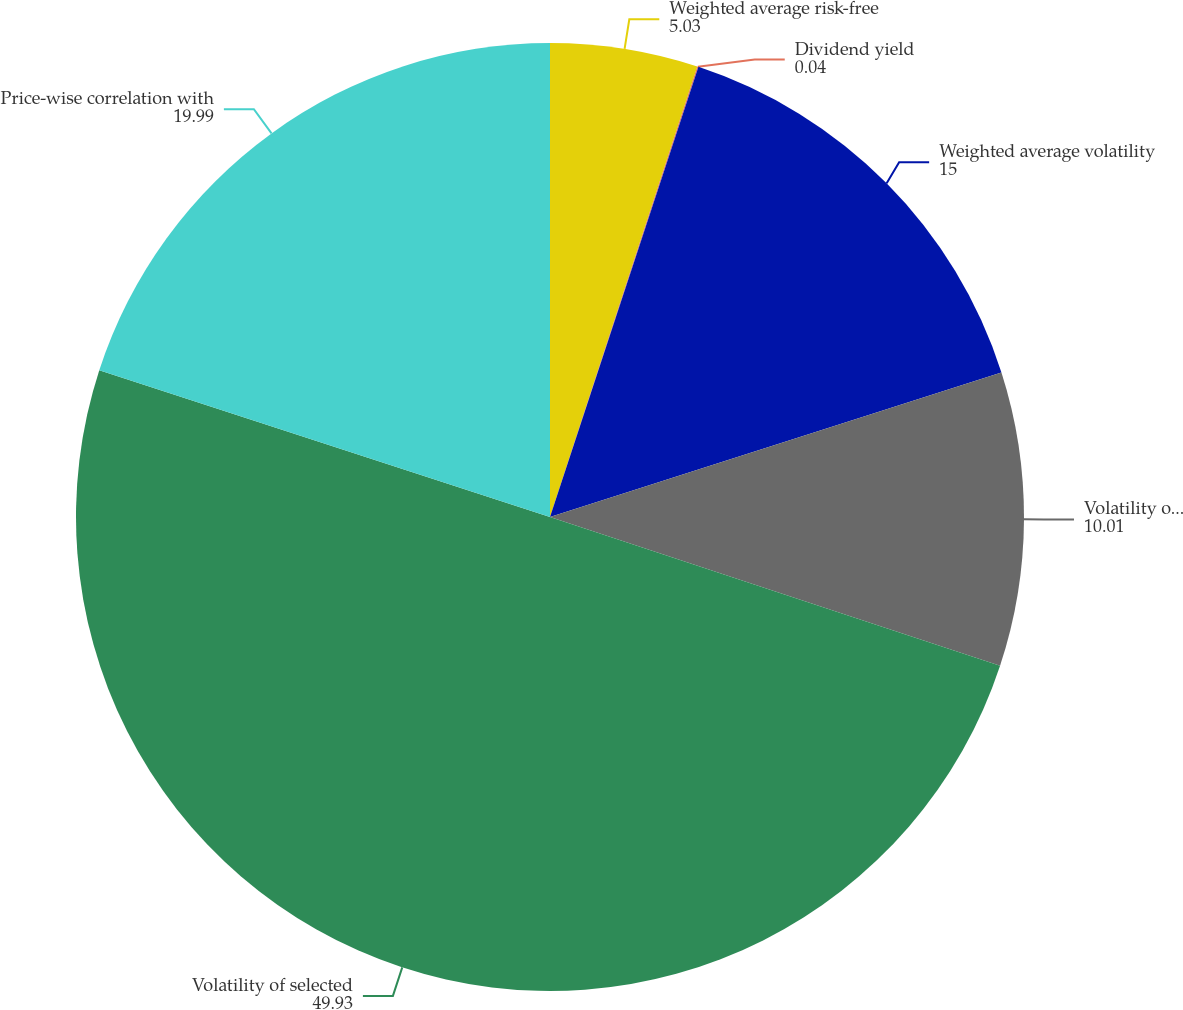<chart> <loc_0><loc_0><loc_500><loc_500><pie_chart><fcel>Weighted average risk-free<fcel>Dividend yield<fcel>Weighted average volatility<fcel>Volatility of Agilent shares<fcel>Volatility of selected<fcel>Price-wise correlation with<nl><fcel>5.03%<fcel>0.04%<fcel>15.0%<fcel>10.01%<fcel>49.93%<fcel>19.99%<nl></chart> 